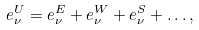<formula> <loc_0><loc_0><loc_500><loc_500>e _ { \nu } ^ { U } = e _ { \nu } ^ { E } + e _ { \nu } ^ { W } + e _ { \nu } ^ { S } + \dots ,</formula> 